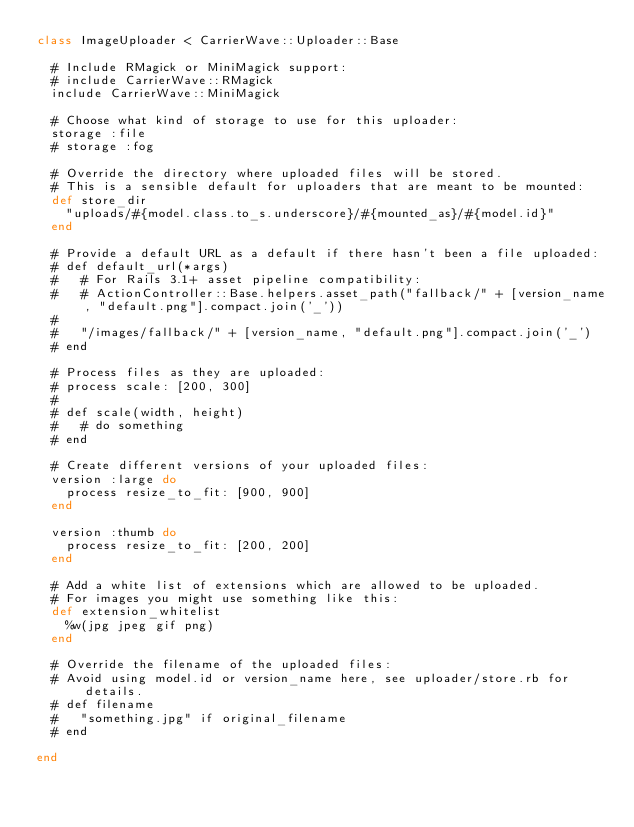<code> <loc_0><loc_0><loc_500><loc_500><_Ruby_>class ImageUploader < CarrierWave::Uploader::Base

  # Include RMagick or MiniMagick support:
  # include CarrierWave::RMagick
  include CarrierWave::MiniMagick

  # Choose what kind of storage to use for this uploader:
  storage :file
  # storage :fog

  # Override the directory where uploaded files will be stored.
  # This is a sensible default for uploaders that are meant to be mounted:
  def store_dir
    "uploads/#{model.class.to_s.underscore}/#{mounted_as}/#{model.id}"
  end

  # Provide a default URL as a default if there hasn't been a file uploaded:
  # def default_url(*args)
  #   # For Rails 3.1+ asset pipeline compatibility:
  #   # ActionController::Base.helpers.asset_path("fallback/" + [version_name, "default.png"].compact.join('_'))
  #
  #   "/images/fallback/" + [version_name, "default.png"].compact.join('_')
  # end

  # Process files as they are uploaded:
  # process scale: [200, 300]
  #
  # def scale(width, height)
  #   # do something
  # end

  # Create different versions of your uploaded files:
  version :large do
    process resize_to_fit: [900, 900]
  end

  version :thumb do
    process resize_to_fit: [200, 200]
  end

  # Add a white list of extensions which are allowed to be uploaded.
  # For images you might use something like this:
  def extension_whitelist
    %w(jpg jpeg gif png)
  end

  # Override the filename of the uploaded files:
  # Avoid using model.id or version_name here, see uploader/store.rb for details.
  # def filename
  #   "something.jpg" if original_filename
  # end

end
</code> 